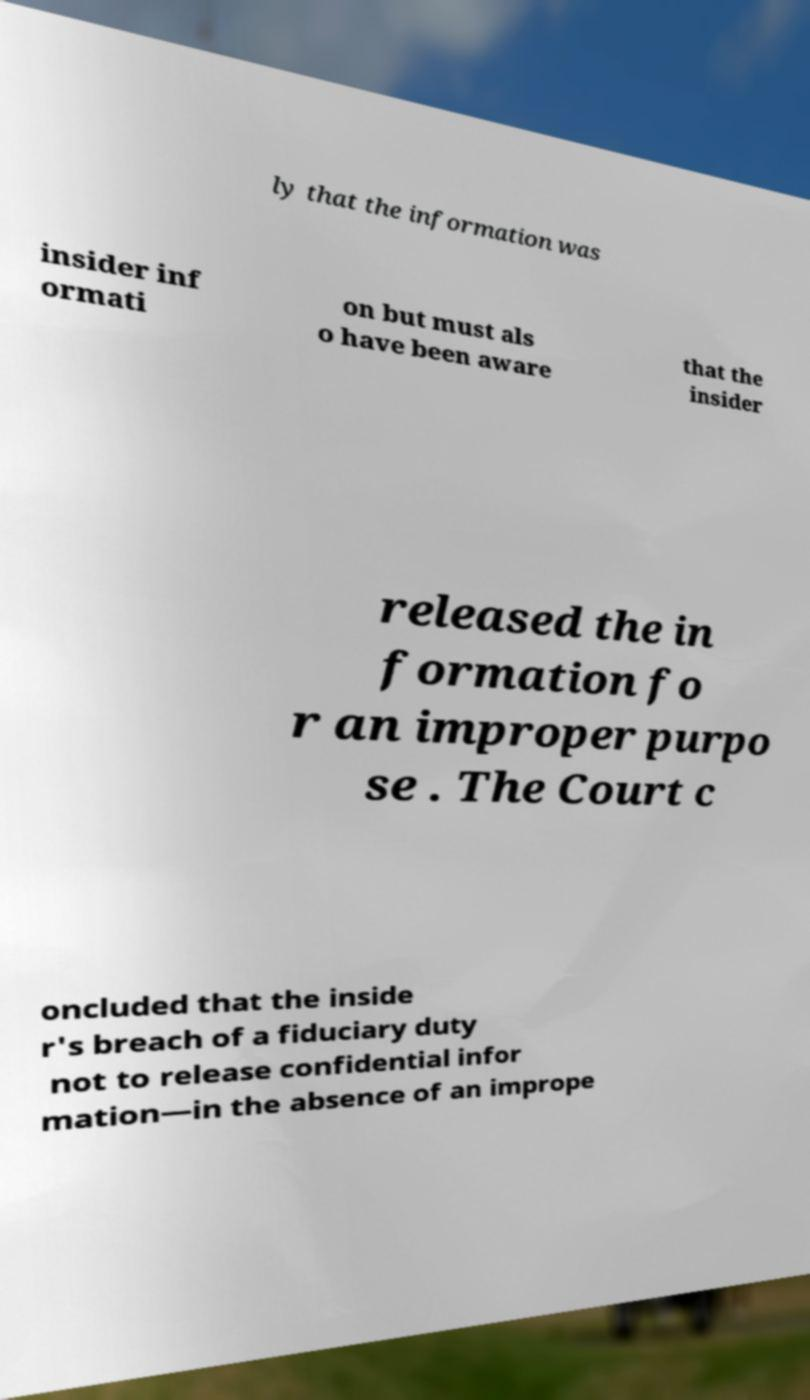Please identify and transcribe the text found in this image. ly that the information was insider inf ormati on but must als o have been aware that the insider released the in formation fo r an improper purpo se . The Court c oncluded that the inside r's breach of a fiduciary duty not to release confidential infor mation—in the absence of an imprope 